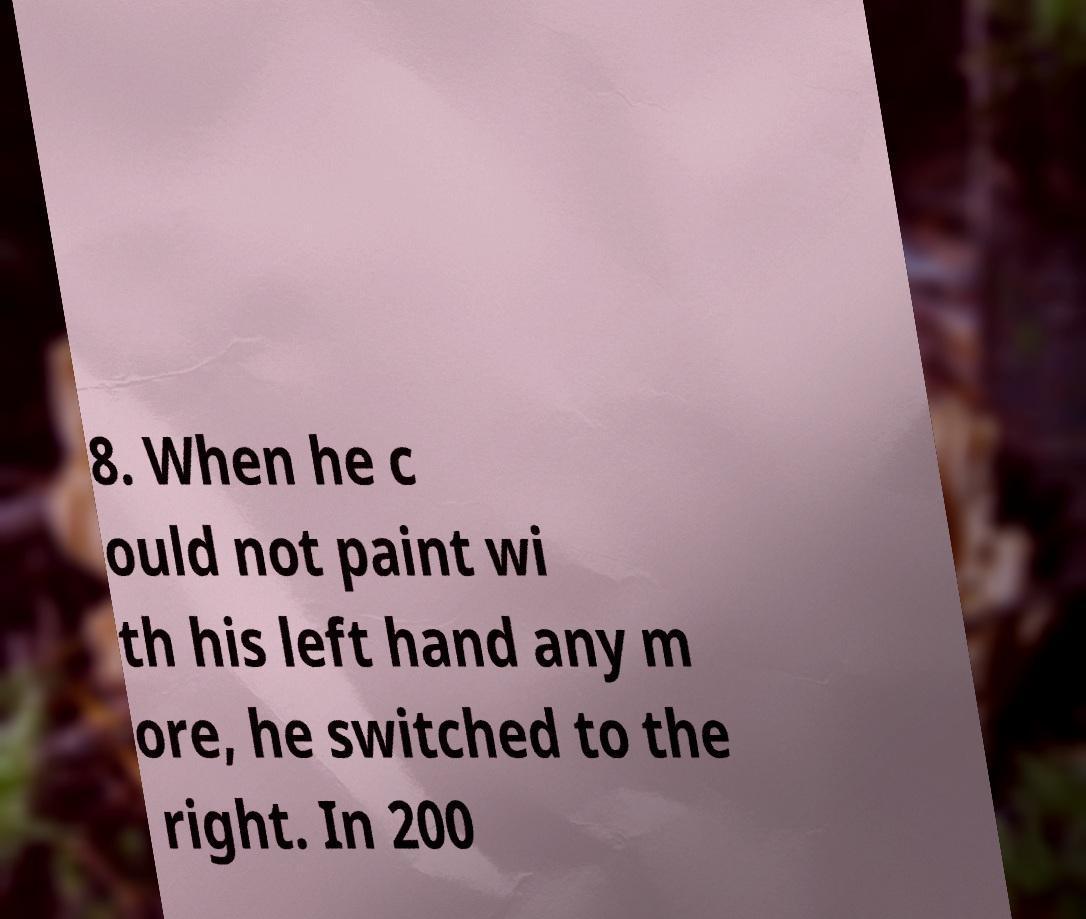What messages or text are displayed in this image? I need them in a readable, typed format. 8. When he c ould not paint wi th his left hand any m ore, he switched to the right. In 200 